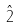Convert formula to latex. <formula><loc_0><loc_0><loc_500><loc_500>\hat { 2 }</formula> 